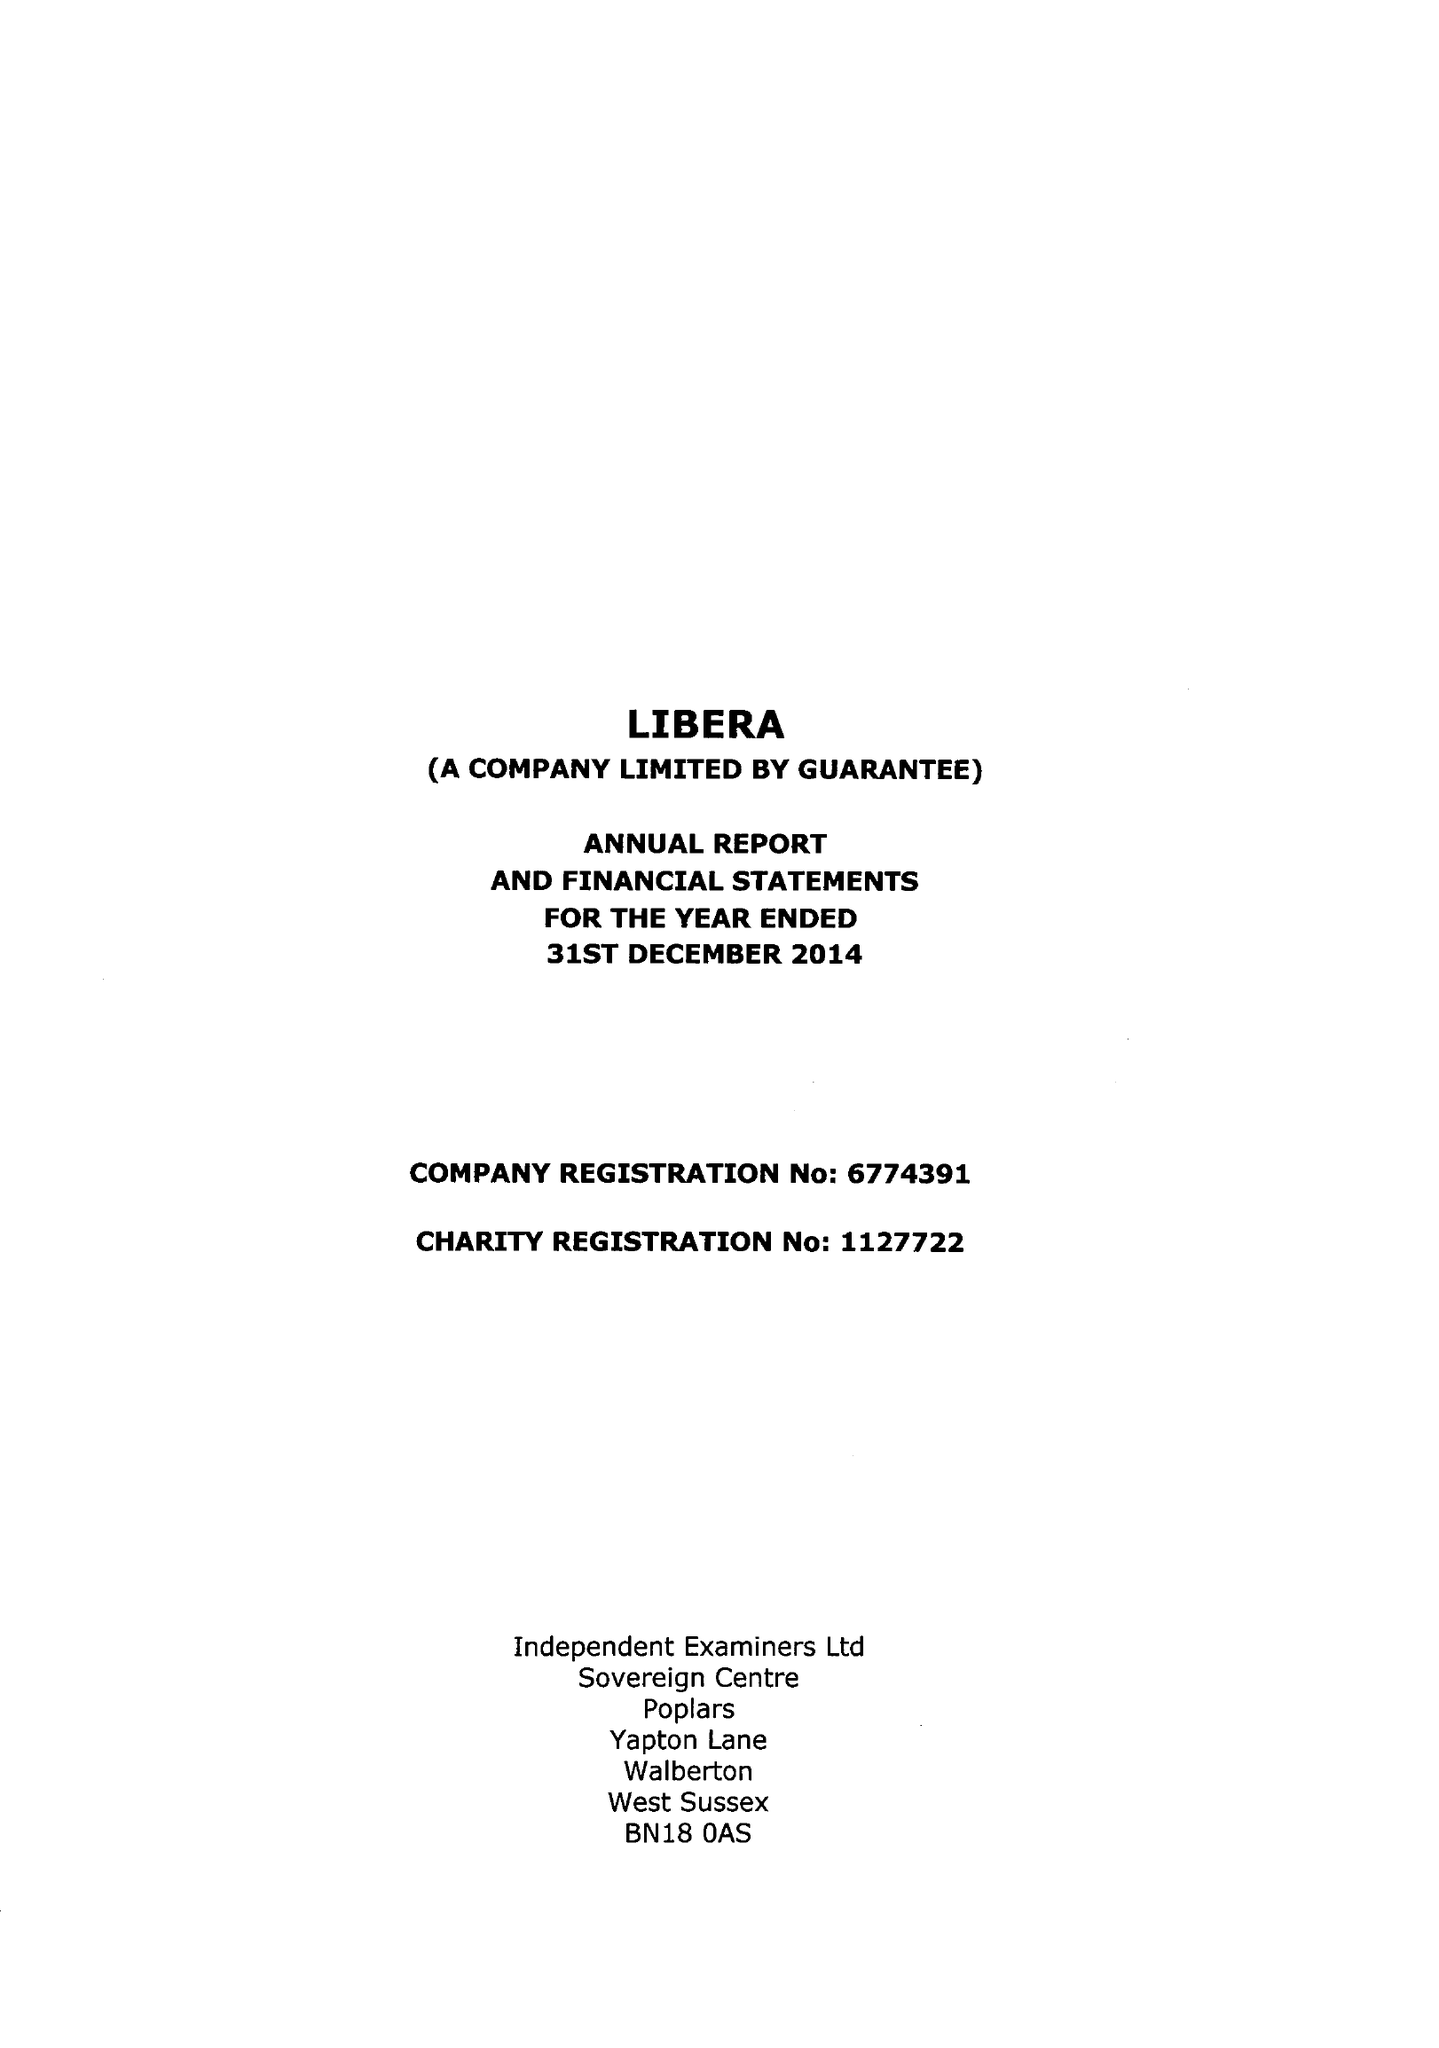What is the value for the charity_number?
Answer the question using a single word or phrase. 1127722 